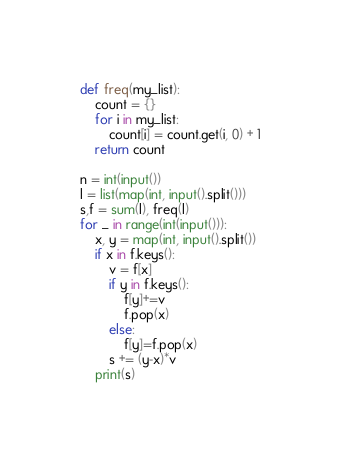Convert code to text. <code><loc_0><loc_0><loc_500><loc_500><_Python_>def freq(my_list):
    count = {} 
    for i in my_list: 
        count[i] = count.get(i, 0) + 1
    return count

n = int(input())
l = list(map(int, input().split()))
s,f = sum(l), freq(l)
for _ in range(int(input())):
    x, y = map(int, input().split())
    if x in f.keys():
        v = f[x]
        if y in f.keys():
            f[y]+=v
            f.pop(x)
        else:
            f[y]=f.pop(x)
        s += (y-x)*v
    print(s)</code> 